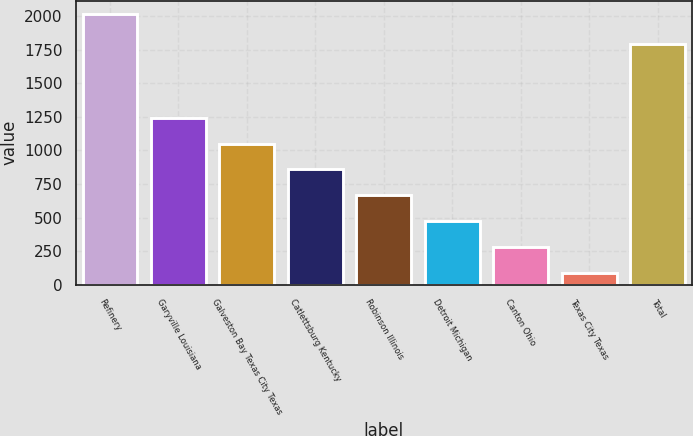Convert chart. <chart><loc_0><loc_0><loc_500><loc_500><bar_chart><fcel>Refinery<fcel>Garyville Louisiana<fcel>Galveston Bay Texas City Texas<fcel>Catlettsburg Kentucky<fcel>Robinson Illinois<fcel>Detroit Michigan<fcel>Canton Ohio<fcel>Texas City Texas<fcel>Total<nl><fcel>2015<fcel>1243.4<fcel>1050.5<fcel>857.6<fcel>664.7<fcel>471.8<fcel>278.9<fcel>86<fcel>1794<nl></chart> 